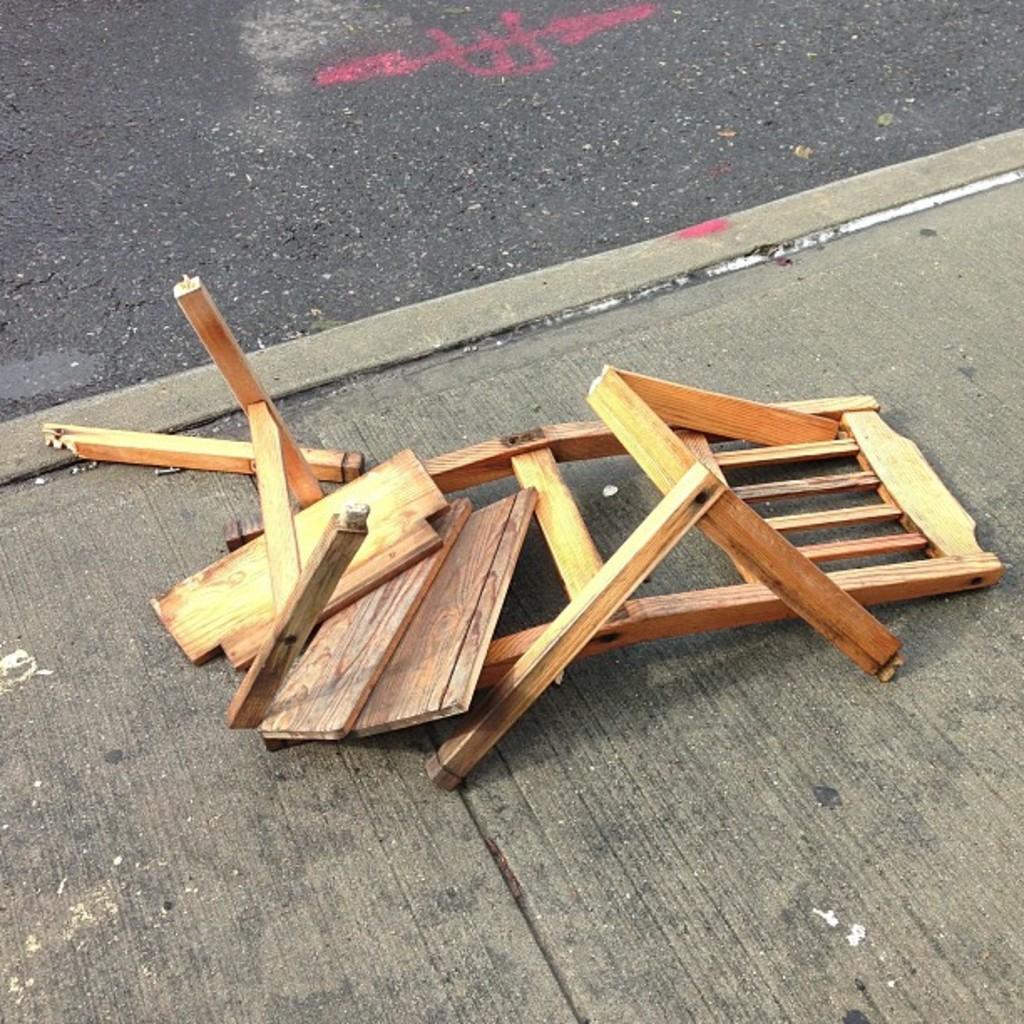Can you describe this image briefly? In this picture there is a broken wooden chair placed on the road. 